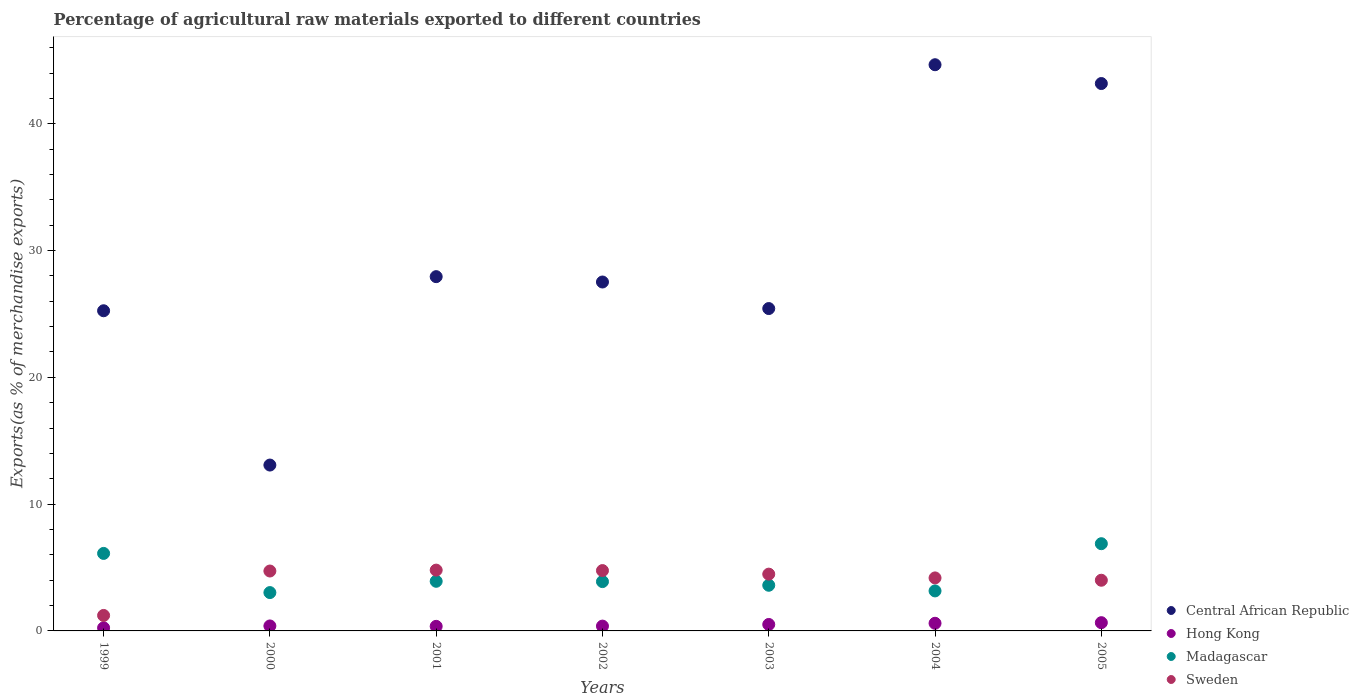What is the percentage of exports to different countries in Central African Republic in 2002?
Provide a succinct answer. 27.52. Across all years, what is the maximum percentage of exports to different countries in Hong Kong?
Make the answer very short. 0.65. Across all years, what is the minimum percentage of exports to different countries in Hong Kong?
Your response must be concise. 0.24. What is the total percentage of exports to different countries in Sweden in the graph?
Offer a very short reply. 28.15. What is the difference between the percentage of exports to different countries in Madagascar in 2002 and that in 2004?
Provide a short and direct response. 0.73. What is the difference between the percentage of exports to different countries in Hong Kong in 1999 and the percentage of exports to different countries in Madagascar in 2005?
Make the answer very short. -6.64. What is the average percentage of exports to different countries in Madagascar per year?
Offer a terse response. 4.37. In the year 2003, what is the difference between the percentage of exports to different countries in Hong Kong and percentage of exports to different countries in Central African Republic?
Give a very brief answer. -24.91. In how many years, is the percentage of exports to different countries in Madagascar greater than 16 %?
Your response must be concise. 0. What is the ratio of the percentage of exports to different countries in Hong Kong in 2002 to that in 2004?
Provide a succinct answer. 0.63. Is the difference between the percentage of exports to different countries in Hong Kong in 1999 and 2002 greater than the difference between the percentage of exports to different countries in Central African Republic in 1999 and 2002?
Your answer should be very brief. Yes. What is the difference between the highest and the second highest percentage of exports to different countries in Sweden?
Provide a short and direct response. 0.04. What is the difference between the highest and the lowest percentage of exports to different countries in Hong Kong?
Ensure brevity in your answer.  0.41. In how many years, is the percentage of exports to different countries in Central African Republic greater than the average percentage of exports to different countries in Central African Republic taken over all years?
Offer a terse response. 2. Is the sum of the percentage of exports to different countries in Madagascar in 2003 and 2005 greater than the maximum percentage of exports to different countries in Hong Kong across all years?
Give a very brief answer. Yes. Is it the case that in every year, the sum of the percentage of exports to different countries in Central African Republic and percentage of exports to different countries in Sweden  is greater than the sum of percentage of exports to different countries in Hong Kong and percentage of exports to different countries in Madagascar?
Your response must be concise. No. Is the percentage of exports to different countries in Central African Republic strictly greater than the percentage of exports to different countries in Madagascar over the years?
Your answer should be compact. Yes. Is the percentage of exports to different countries in Central African Republic strictly less than the percentage of exports to different countries in Hong Kong over the years?
Give a very brief answer. No. How many dotlines are there?
Provide a succinct answer. 4. How many years are there in the graph?
Your answer should be very brief. 7. How many legend labels are there?
Your answer should be very brief. 4. What is the title of the graph?
Your answer should be very brief. Percentage of agricultural raw materials exported to different countries. What is the label or title of the Y-axis?
Provide a succinct answer. Exports(as % of merchandise exports). What is the Exports(as % of merchandise exports) of Central African Republic in 1999?
Provide a short and direct response. 25.25. What is the Exports(as % of merchandise exports) of Hong Kong in 1999?
Your answer should be very brief. 0.24. What is the Exports(as % of merchandise exports) in Madagascar in 1999?
Provide a short and direct response. 6.11. What is the Exports(as % of merchandise exports) of Sweden in 1999?
Offer a terse response. 1.22. What is the Exports(as % of merchandise exports) in Central African Republic in 2000?
Give a very brief answer. 13.08. What is the Exports(as % of merchandise exports) of Hong Kong in 2000?
Your answer should be compact. 0.39. What is the Exports(as % of merchandise exports) of Madagascar in 2000?
Your answer should be compact. 3.02. What is the Exports(as % of merchandise exports) of Sweden in 2000?
Offer a terse response. 4.72. What is the Exports(as % of merchandise exports) in Central African Republic in 2001?
Offer a terse response. 27.94. What is the Exports(as % of merchandise exports) of Hong Kong in 2001?
Offer a terse response. 0.36. What is the Exports(as % of merchandise exports) in Madagascar in 2001?
Your answer should be compact. 3.91. What is the Exports(as % of merchandise exports) in Sweden in 2001?
Offer a very short reply. 4.8. What is the Exports(as % of merchandise exports) in Central African Republic in 2002?
Ensure brevity in your answer.  27.52. What is the Exports(as % of merchandise exports) in Hong Kong in 2002?
Offer a very short reply. 0.38. What is the Exports(as % of merchandise exports) in Madagascar in 2002?
Offer a terse response. 3.89. What is the Exports(as % of merchandise exports) of Sweden in 2002?
Make the answer very short. 4.76. What is the Exports(as % of merchandise exports) of Central African Republic in 2003?
Make the answer very short. 25.42. What is the Exports(as % of merchandise exports) of Hong Kong in 2003?
Your response must be concise. 0.51. What is the Exports(as % of merchandise exports) in Madagascar in 2003?
Give a very brief answer. 3.6. What is the Exports(as % of merchandise exports) in Sweden in 2003?
Your answer should be compact. 4.48. What is the Exports(as % of merchandise exports) of Central African Republic in 2004?
Make the answer very short. 44.65. What is the Exports(as % of merchandise exports) of Hong Kong in 2004?
Make the answer very short. 0.6. What is the Exports(as % of merchandise exports) in Madagascar in 2004?
Make the answer very short. 3.16. What is the Exports(as % of merchandise exports) in Sweden in 2004?
Provide a succinct answer. 4.18. What is the Exports(as % of merchandise exports) of Central African Republic in 2005?
Ensure brevity in your answer.  43.17. What is the Exports(as % of merchandise exports) of Hong Kong in 2005?
Provide a short and direct response. 0.65. What is the Exports(as % of merchandise exports) of Madagascar in 2005?
Ensure brevity in your answer.  6.88. What is the Exports(as % of merchandise exports) in Sweden in 2005?
Keep it short and to the point. 4. Across all years, what is the maximum Exports(as % of merchandise exports) of Central African Republic?
Provide a succinct answer. 44.65. Across all years, what is the maximum Exports(as % of merchandise exports) of Hong Kong?
Provide a short and direct response. 0.65. Across all years, what is the maximum Exports(as % of merchandise exports) in Madagascar?
Your response must be concise. 6.88. Across all years, what is the maximum Exports(as % of merchandise exports) in Sweden?
Offer a terse response. 4.8. Across all years, what is the minimum Exports(as % of merchandise exports) of Central African Republic?
Keep it short and to the point. 13.08. Across all years, what is the minimum Exports(as % of merchandise exports) of Hong Kong?
Give a very brief answer. 0.24. Across all years, what is the minimum Exports(as % of merchandise exports) of Madagascar?
Ensure brevity in your answer.  3.02. Across all years, what is the minimum Exports(as % of merchandise exports) in Sweden?
Your answer should be very brief. 1.22. What is the total Exports(as % of merchandise exports) of Central African Republic in the graph?
Your answer should be very brief. 207.03. What is the total Exports(as % of merchandise exports) of Hong Kong in the graph?
Your answer should be compact. 3.14. What is the total Exports(as % of merchandise exports) of Madagascar in the graph?
Your response must be concise. 30.57. What is the total Exports(as % of merchandise exports) of Sweden in the graph?
Your answer should be compact. 28.15. What is the difference between the Exports(as % of merchandise exports) of Central African Republic in 1999 and that in 2000?
Provide a succinct answer. 12.17. What is the difference between the Exports(as % of merchandise exports) of Hong Kong in 1999 and that in 2000?
Ensure brevity in your answer.  -0.15. What is the difference between the Exports(as % of merchandise exports) of Madagascar in 1999 and that in 2000?
Ensure brevity in your answer.  3.09. What is the difference between the Exports(as % of merchandise exports) of Sweden in 1999 and that in 2000?
Provide a short and direct response. -3.5. What is the difference between the Exports(as % of merchandise exports) in Central African Republic in 1999 and that in 2001?
Provide a succinct answer. -2.69. What is the difference between the Exports(as % of merchandise exports) in Hong Kong in 1999 and that in 2001?
Provide a succinct answer. -0.12. What is the difference between the Exports(as % of merchandise exports) in Madagascar in 1999 and that in 2001?
Offer a very short reply. 2.2. What is the difference between the Exports(as % of merchandise exports) in Sweden in 1999 and that in 2001?
Give a very brief answer. -3.57. What is the difference between the Exports(as % of merchandise exports) in Central African Republic in 1999 and that in 2002?
Provide a succinct answer. -2.27. What is the difference between the Exports(as % of merchandise exports) in Hong Kong in 1999 and that in 2002?
Offer a very short reply. -0.14. What is the difference between the Exports(as % of merchandise exports) of Madagascar in 1999 and that in 2002?
Give a very brief answer. 2.22. What is the difference between the Exports(as % of merchandise exports) of Sweden in 1999 and that in 2002?
Your answer should be compact. -3.54. What is the difference between the Exports(as % of merchandise exports) in Central African Republic in 1999 and that in 2003?
Your answer should be compact. -0.17. What is the difference between the Exports(as % of merchandise exports) of Hong Kong in 1999 and that in 2003?
Ensure brevity in your answer.  -0.27. What is the difference between the Exports(as % of merchandise exports) in Madagascar in 1999 and that in 2003?
Your response must be concise. 2.51. What is the difference between the Exports(as % of merchandise exports) in Sweden in 1999 and that in 2003?
Give a very brief answer. -3.26. What is the difference between the Exports(as % of merchandise exports) of Central African Republic in 1999 and that in 2004?
Your response must be concise. -19.4. What is the difference between the Exports(as % of merchandise exports) of Hong Kong in 1999 and that in 2004?
Ensure brevity in your answer.  -0.36. What is the difference between the Exports(as % of merchandise exports) of Madagascar in 1999 and that in 2004?
Provide a short and direct response. 2.96. What is the difference between the Exports(as % of merchandise exports) of Sweden in 1999 and that in 2004?
Ensure brevity in your answer.  -2.96. What is the difference between the Exports(as % of merchandise exports) in Central African Republic in 1999 and that in 2005?
Make the answer very short. -17.92. What is the difference between the Exports(as % of merchandise exports) of Hong Kong in 1999 and that in 2005?
Offer a very short reply. -0.41. What is the difference between the Exports(as % of merchandise exports) of Madagascar in 1999 and that in 2005?
Give a very brief answer. -0.77. What is the difference between the Exports(as % of merchandise exports) of Sweden in 1999 and that in 2005?
Offer a terse response. -2.78. What is the difference between the Exports(as % of merchandise exports) in Central African Republic in 2000 and that in 2001?
Make the answer very short. -14.86. What is the difference between the Exports(as % of merchandise exports) in Hong Kong in 2000 and that in 2001?
Give a very brief answer. 0.03. What is the difference between the Exports(as % of merchandise exports) in Madagascar in 2000 and that in 2001?
Provide a short and direct response. -0.89. What is the difference between the Exports(as % of merchandise exports) of Sweden in 2000 and that in 2001?
Offer a very short reply. -0.07. What is the difference between the Exports(as % of merchandise exports) of Central African Republic in 2000 and that in 2002?
Give a very brief answer. -14.44. What is the difference between the Exports(as % of merchandise exports) in Hong Kong in 2000 and that in 2002?
Provide a succinct answer. 0.01. What is the difference between the Exports(as % of merchandise exports) of Madagascar in 2000 and that in 2002?
Make the answer very short. -0.87. What is the difference between the Exports(as % of merchandise exports) of Sweden in 2000 and that in 2002?
Ensure brevity in your answer.  -0.03. What is the difference between the Exports(as % of merchandise exports) of Central African Republic in 2000 and that in 2003?
Provide a short and direct response. -12.34. What is the difference between the Exports(as % of merchandise exports) in Hong Kong in 2000 and that in 2003?
Your answer should be compact. -0.12. What is the difference between the Exports(as % of merchandise exports) of Madagascar in 2000 and that in 2003?
Give a very brief answer. -0.58. What is the difference between the Exports(as % of merchandise exports) of Sweden in 2000 and that in 2003?
Ensure brevity in your answer.  0.25. What is the difference between the Exports(as % of merchandise exports) of Central African Republic in 2000 and that in 2004?
Keep it short and to the point. -31.57. What is the difference between the Exports(as % of merchandise exports) in Hong Kong in 2000 and that in 2004?
Offer a very short reply. -0.21. What is the difference between the Exports(as % of merchandise exports) in Madagascar in 2000 and that in 2004?
Your response must be concise. -0.13. What is the difference between the Exports(as % of merchandise exports) in Sweden in 2000 and that in 2004?
Offer a terse response. 0.54. What is the difference between the Exports(as % of merchandise exports) of Central African Republic in 2000 and that in 2005?
Your response must be concise. -30.09. What is the difference between the Exports(as % of merchandise exports) in Hong Kong in 2000 and that in 2005?
Your response must be concise. -0.26. What is the difference between the Exports(as % of merchandise exports) in Madagascar in 2000 and that in 2005?
Offer a very short reply. -3.85. What is the difference between the Exports(as % of merchandise exports) of Sweden in 2000 and that in 2005?
Ensure brevity in your answer.  0.73. What is the difference between the Exports(as % of merchandise exports) of Central African Republic in 2001 and that in 2002?
Keep it short and to the point. 0.42. What is the difference between the Exports(as % of merchandise exports) of Hong Kong in 2001 and that in 2002?
Provide a succinct answer. -0.02. What is the difference between the Exports(as % of merchandise exports) of Madagascar in 2001 and that in 2002?
Your answer should be compact. 0.02. What is the difference between the Exports(as % of merchandise exports) in Sweden in 2001 and that in 2002?
Your response must be concise. 0.04. What is the difference between the Exports(as % of merchandise exports) of Central African Republic in 2001 and that in 2003?
Provide a succinct answer. 2.52. What is the difference between the Exports(as % of merchandise exports) in Hong Kong in 2001 and that in 2003?
Your response must be concise. -0.15. What is the difference between the Exports(as % of merchandise exports) in Madagascar in 2001 and that in 2003?
Ensure brevity in your answer.  0.31. What is the difference between the Exports(as % of merchandise exports) of Sweden in 2001 and that in 2003?
Ensure brevity in your answer.  0.32. What is the difference between the Exports(as % of merchandise exports) of Central African Republic in 2001 and that in 2004?
Provide a short and direct response. -16.71. What is the difference between the Exports(as % of merchandise exports) of Hong Kong in 2001 and that in 2004?
Your response must be concise. -0.24. What is the difference between the Exports(as % of merchandise exports) in Madagascar in 2001 and that in 2004?
Keep it short and to the point. 0.76. What is the difference between the Exports(as % of merchandise exports) of Sweden in 2001 and that in 2004?
Keep it short and to the point. 0.61. What is the difference between the Exports(as % of merchandise exports) in Central African Republic in 2001 and that in 2005?
Provide a succinct answer. -15.23. What is the difference between the Exports(as % of merchandise exports) in Hong Kong in 2001 and that in 2005?
Your answer should be compact. -0.29. What is the difference between the Exports(as % of merchandise exports) of Madagascar in 2001 and that in 2005?
Ensure brevity in your answer.  -2.96. What is the difference between the Exports(as % of merchandise exports) in Sweden in 2001 and that in 2005?
Your response must be concise. 0.8. What is the difference between the Exports(as % of merchandise exports) in Central African Republic in 2002 and that in 2003?
Offer a terse response. 2.09. What is the difference between the Exports(as % of merchandise exports) of Hong Kong in 2002 and that in 2003?
Make the answer very short. -0.13. What is the difference between the Exports(as % of merchandise exports) in Madagascar in 2002 and that in 2003?
Your answer should be very brief. 0.29. What is the difference between the Exports(as % of merchandise exports) of Sweden in 2002 and that in 2003?
Make the answer very short. 0.28. What is the difference between the Exports(as % of merchandise exports) of Central African Republic in 2002 and that in 2004?
Your response must be concise. -17.14. What is the difference between the Exports(as % of merchandise exports) in Hong Kong in 2002 and that in 2004?
Offer a terse response. -0.22. What is the difference between the Exports(as % of merchandise exports) of Madagascar in 2002 and that in 2004?
Give a very brief answer. 0.73. What is the difference between the Exports(as % of merchandise exports) in Sweden in 2002 and that in 2004?
Offer a terse response. 0.58. What is the difference between the Exports(as % of merchandise exports) of Central African Republic in 2002 and that in 2005?
Provide a succinct answer. -15.65. What is the difference between the Exports(as % of merchandise exports) in Hong Kong in 2002 and that in 2005?
Keep it short and to the point. -0.27. What is the difference between the Exports(as % of merchandise exports) in Madagascar in 2002 and that in 2005?
Ensure brevity in your answer.  -2.99. What is the difference between the Exports(as % of merchandise exports) in Sweden in 2002 and that in 2005?
Keep it short and to the point. 0.76. What is the difference between the Exports(as % of merchandise exports) of Central African Republic in 2003 and that in 2004?
Your answer should be very brief. -19.23. What is the difference between the Exports(as % of merchandise exports) in Hong Kong in 2003 and that in 2004?
Your response must be concise. -0.09. What is the difference between the Exports(as % of merchandise exports) in Madagascar in 2003 and that in 2004?
Provide a short and direct response. 0.45. What is the difference between the Exports(as % of merchandise exports) of Sweden in 2003 and that in 2004?
Offer a very short reply. 0.3. What is the difference between the Exports(as % of merchandise exports) of Central African Republic in 2003 and that in 2005?
Your answer should be compact. -17.75. What is the difference between the Exports(as % of merchandise exports) of Hong Kong in 2003 and that in 2005?
Ensure brevity in your answer.  -0.14. What is the difference between the Exports(as % of merchandise exports) in Madagascar in 2003 and that in 2005?
Provide a short and direct response. -3.28. What is the difference between the Exports(as % of merchandise exports) of Sweden in 2003 and that in 2005?
Your response must be concise. 0.48. What is the difference between the Exports(as % of merchandise exports) in Central African Republic in 2004 and that in 2005?
Offer a very short reply. 1.48. What is the difference between the Exports(as % of merchandise exports) in Hong Kong in 2004 and that in 2005?
Your answer should be very brief. -0.05. What is the difference between the Exports(as % of merchandise exports) of Madagascar in 2004 and that in 2005?
Your answer should be compact. -3.72. What is the difference between the Exports(as % of merchandise exports) of Sweden in 2004 and that in 2005?
Your response must be concise. 0.18. What is the difference between the Exports(as % of merchandise exports) in Central African Republic in 1999 and the Exports(as % of merchandise exports) in Hong Kong in 2000?
Your response must be concise. 24.86. What is the difference between the Exports(as % of merchandise exports) of Central African Republic in 1999 and the Exports(as % of merchandise exports) of Madagascar in 2000?
Ensure brevity in your answer.  22.23. What is the difference between the Exports(as % of merchandise exports) in Central African Republic in 1999 and the Exports(as % of merchandise exports) in Sweden in 2000?
Offer a very short reply. 20.52. What is the difference between the Exports(as % of merchandise exports) of Hong Kong in 1999 and the Exports(as % of merchandise exports) of Madagascar in 2000?
Provide a succinct answer. -2.78. What is the difference between the Exports(as % of merchandise exports) in Hong Kong in 1999 and the Exports(as % of merchandise exports) in Sweden in 2000?
Offer a very short reply. -4.48. What is the difference between the Exports(as % of merchandise exports) of Madagascar in 1999 and the Exports(as % of merchandise exports) of Sweden in 2000?
Provide a short and direct response. 1.39. What is the difference between the Exports(as % of merchandise exports) in Central African Republic in 1999 and the Exports(as % of merchandise exports) in Hong Kong in 2001?
Your response must be concise. 24.89. What is the difference between the Exports(as % of merchandise exports) of Central African Republic in 1999 and the Exports(as % of merchandise exports) of Madagascar in 2001?
Your answer should be very brief. 21.33. What is the difference between the Exports(as % of merchandise exports) in Central African Republic in 1999 and the Exports(as % of merchandise exports) in Sweden in 2001?
Offer a very short reply. 20.45. What is the difference between the Exports(as % of merchandise exports) of Hong Kong in 1999 and the Exports(as % of merchandise exports) of Madagascar in 2001?
Offer a terse response. -3.67. What is the difference between the Exports(as % of merchandise exports) of Hong Kong in 1999 and the Exports(as % of merchandise exports) of Sweden in 2001?
Ensure brevity in your answer.  -4.55. What is the difference between the Exports(as % of merchandise exports) in Madagascar in 1999 and the Exports(as % of merchandise exports) in Sweden in 2001?
Your response must be concise. 1.32. What is the difference between the Exports(as % of merchandise exports) in Central African Republic in 1999 and the Exports(as % of merchandise exports) in Hong Kong in 2002?
Your response must be concise. 24.87. What is the difference between the Exports(as % of merchandise exports) of Central African Republic in 1999 and the Exports(as % of merchandise exports) of Madagascar in 2002?
Provide a succinct answer. 21.36. What is the difference between the Exports(as % of merchandise exports) of Central African Republic in 1999 and the Exports(as % of merchandise exports) of Sweden in 2002?
Your response must be concise. 20.49. What is the difference between the Exports(as % of merchandise exports) of Hong Kong in 1999 and the Exports(as % of merchandise exports) of Madagascar in 2002?
Keep it short and to the point. -3.65. What is the difference between the Exports(as % of merchandise exports) of Hong Kong in 1999 and the Exports(as % of merchandise exports) of Sweden in 2002?
Offer a terse response. -4.52. What is the difference between the Exports(as % of merchandise exports) of Madagascar in 1999 and the Exports(as % of merchandise exports) of Sweden in 2002?
Offer a very short reply. 1.35. What is the difference between the Exports(as % of merchandise exports) in Central African Republic in 1999 and the Exports(as % of merchandise exports) in Hong Kong in 2003?
Provide a succinct answer. 24.74. What is the difference between the Exports(as % of merchandise exports) of Central African Republic in 1999 and the Exports(as % of merchandise exports) of Madagascar in 2003?
Your answer should be compact. 21.65. What is the difference between the Exports(as % of merchandise exports) in Central African Republic in 1999 and the Exports(as % of merchandise exports) in Sweden in 2003?
Make the answer very short. 20.77. What is the difference between the Exports(as % of merchandise exports) of Hong Kong in 1999 and the Exports(as % of merchandise exports) of Madagascar in 2003?
Provide a short and direct response. -3.36. What is the difference between the Exports(as % of merchandise exports) in Hong Kong in 1999 and the Exports(as % of merchandise exports) in Sweden in 2003?
Your answer should be very brief. -4.24. What is the difference between the Exports(as % of merchandise exports) in Madagascar in 1999 and the Exports(as % of merchandise exports) in Sweden in 2003?
Make the answer very short. 1.63. What is the difference between the Exports(as % of merchandise exports) in Central African Republic in 1999 and the Exports(as % of merchandise exports) in Hong Kong in 2004?
Keep it short and to the point. 24.65. What is the difference between the Exports(as % of merchandise exports) in Central African Republic in 1999 and the Exports(as % of merchandise exports) in Madagascar in 2004?
Provide a succinct answer. 22.09. What is the difference between the Exports(as % of merchandise exports) in Central African Republic in 1999 and the Exports(as % of merchandise exports) in Sweden in 2004?
Keep it short and to the point. 21.07. What is the difference between the Exports(as % of merchandise exports) of Hong Kong in 1999 and the Exports(as % of merchandise exports) of Madagascar in 2004?
Provide a short and direct response. -2.91. What is the difference between the Exports(as % of merchandise exports) of Hong Kong in 1999 and the Exports(as % of merchandise exports) of Sweden in 2004?
Ensure brevity in your answer.  -3.94. What is the difference between the Exports(as % of merchandise exports) in Madagascar in 1999 and the Exports(as % of merchandise exports) in Sweden in 2004?
Give a very brief answer. 1.93. What is the difference between the Exports(as % of merchandise exports) of Central African Republic in 1999 and the Exports(as % of merchandise exports) of Hong Kong in 2005?
Offer a terse response. 24.6. What is the difference between the Exports(as % of merchandise exports) of Central African Republic in 1999 and the Exports(as % of merchandise exports) of Madagascar in 2005?
Ensure brevity in your answer.  18.37. What is the difference between the Exports(as % of merchandise exports) of Central African Republic in 1999 and the Exports(as % of merchandise exports) of Sweden in 2005?
Keep it short and to the point. 21.25. What is the difference between the Exports(as % of merchandise exports) in Hong Kong in 1999 and the Exports(as % of merchandise exports) in Madagascar in 2005?
Your response must be concise. -6.64. What is the difference between the Exports(as % of merchandise exports) of Hong Kong in 1999 and the Exports(as % of merchandise exports) of Sweden in 2005?
Offer a very short reply. -3.75. What is the difference between the Exports(as % of merchandise exports) in Madagascar in 1999 and the Exports(as % of merchandise exports) in Sweden in 2005?
Your answer should be compact. 2.12. What is the difference between the Exports(as % of merchandise exports) of Central African Republic in 2000 and the Exports(as % of merchandise exports) of Hong Kong in 2001?
Provide a short and direct response. 12.72. What is the difference between the Exports(as % of merchandise exports) in Central African Republic in 2000 and the Exports(as % of merchandise exports) in Madagascar in 2001?
Give a very brief answer. 9.17. What is the difference between the Exports(as % of merchandise exports) of Central African Republic in 2000 and the Exports(as % of merchandise exports) of Sweden in 2001?
Provide a short and direct response. 8.29. What is the difference between the Exports(as % of merchandise exports) of Hong Kong in 2000 and the Exports(as % of merchandise exports) of Madagascar in 2001?
Offer a terse response. -3.52. What is the difference between the Exports(as % of merchandise exports) of Hong Kong in 2000 and the Exports(as % of merchandise exports) of Sweden in 2001?
Your answer should be very brief. -4.4. What is the difference between the Exports(as % of merchandise exports) of Madagascar in 2000 and the Exports(as % of merchandise exports) of Sweden in 2001?
Your response must be concise. -1.77. What is the difference between the Exports(as % of merchandise exports) in Central African Republic in 2000 and the Exports(as % of merchandise exports) in Hong Kong in 2002?
Your answer should be very brief. 12.7. What is the difference between the Exports(as % of merchandise exports) of Central African Republic in 2000 and the Exports(as % of merchandise exports) of Madagascar in 2002?
Keep it short and to the point. 9.19. What is the difference between the Exports(as % of merchandise exports) in Central African Republic in 2000 and the Exports(as % of merchandise exports) in Sweden in 2002?
Your answer should be compact. 8.32. What is the difference between the Exports(as % of merchandise exports) of Hong Kong in 2000 and the Exports(as % of merchandise exports) of Madagascar in 2002?
Provide a short and direct response. -3.5. What is the difference between the Exports(as % of merchandise exports) in Hong Kong in 2000 and the Exports(as % of merchandise exports) in Sweden in 2002?
Offer a very short reply. -4.37. What is the difference between the Exports(as % of merchandise exports) of Madagascar in 2000 and the Exports(as % of merchandise exports) of Sweden in 2002?
Provide a succinct answer. -1.74. What is the difference between the Exports(as % of merchandise exports) of Central African Republic in 2000 and the Exports(as % of merchandise exports) of Hong Kong in 2003?
Provide a succinct answer. 12.57. What is the difference between the Exports(as % of merchandise exports) in Central African Republic in 2000 and the Exports(as % of merchandise exports) in Madagascar in 2003?
Keep it short and to the point. 9.48. What is the difference between the Exports(as % of merchandise exports) of Central African Republic in 2000 and the Exports(as % of merchandise exports) of Sweden in 2003?
Provide a short and direct response. 8.6. What is the difference between the Exports(as % of merchandise exports) of Hong Kong in 2000 and the Exports(as % of merchandise exports) of Madagascar in 2003?
Ensure brevity in your answer.  -3.21. What is the difference between the Exports(as % of merchandise exports) of Hong Kong in 2000 and the Exports(as % of merchandise exports) of Sweden in 2003?
Provide a succinct answer. -4.09. What is the difference between the Exports(as % of merchandise exports) in Madagascar in 2000 and the Exports(as % of merchandise exports) in Sweden in 2003?
Your answer should be very brief. -1.45. What is the difference between the Exports(as % of merchandise exports) of Central African Republic in 2000 and the Exports(as % of merchandise exports) of Hong Kong in 2004?
Your response must be concise. 12.48. What is the difference between the Exports(as % of merchandise exports) of Central African Republic in 2000 and the Exports(as % of merchandise exports) of Madagascar in 2004?
Offer a very short reply. 9.93. What is the difference between the Exports(as % of merchandise exports) of Central African Republic in 2000 and the Exports(as % of merchandise exports) of Sweden in 2004?
Offer a terse response. 8.9. What is the difference between the Exports(as % of merchandise exports) in Hong Kong in 2000 and the Exports(as % of merchandise exports) in Madagascar in 2004?
Provide a succinct answer. -2.76. What is the difference between the Exports(as % of merchandise exports) in Hong Kong in 2000 and the Exports(as % of merchandise exports) in Sweden in 2004?
Offer a terse response. -3.79. What is the difference between the Exports(as % of merchandise exports) of Madagascar in 2000 and the Exports(as % of merchandise exports) of Sweden in 2004?
Make the answer very short. -1.16. What is the difference between the Exports(as % of merchandise exports) of Central African Republic in 2000 and the Exports(as % of merchandise exports) of Hong Kong in 2005?
Offer a very short reply. 12.43. What is the difference between the Exports(as % of merchandise exports) of Central African Republic in 2000 and the Exports(as % of merchandise exports) of Madagascar in 2005?
Offer a terse response. 6.2. What is the difference between the Exports(as % of merchandise exports) in Central African Republic in 2000 and the Exports(as % of merchandise exports) in Sweden in 2005?
Your answer should be very brief. 9.08. What is the difference between the Exports(as % of merchandise exports) of Hong Kong in 2000 and the Exports(as % of merchandise exports) of Madagascar in 2005?
Your answer should be very brief. -6.49. What is the difference between the Exports(as % of merchandise exports) of Hong Kong in 2000 and the Exports(as % of merchandise exports) of Sweden in 2005?
Provide a succinct answer. -3.6. What is the difference between the Exports(as % of merchandise exports) of Madagascar in 2000 and the Exports(as % of merchandise exports) of Sweden in 2005?
Make the answer very short. -0.97. What is the difference between the Exports(as % of merchandise exports) in Central African Republic in 2001 and the Exports(as % of merchandise exports) in Hong Kong in 2002?
Offer a very short reply. 27.56. What is the difference between the Exports(as % of merchandise exports) of Central African Republic in 2001 and the Exports(as % of merchandise exports) of Madagascar in 2002?
Offer a terse response. 24.05. What is the difference between the Exports(as % of merchandise exports) in Central African Republic in 2001 and the Exports(as % of merchandise exports) in Sweden in 2002?
Keep it short and to the point. 23.18. What is the difference between the Exports(as % of merchandise exports) of Hong Kong in 2001 and the Exports(as % of merchandise exports) of Madagascar in 2002?
Keep it short and to the point. -3.53. What is the difference between the Exports(as % of merchandise exports) of Hong Kong in 2001 and the Exports(as % of merchandise exports) of Sweden in 2002?
Offer a terse response. -4.4. What is the difference between the Exports(as % of merchandise exports) of Madagascar in 2001 and the Exports(as % of merchandise exports) of Sweden in 2002?
Your answer should be very brief. -0.84. What is the difference between the Exports(as % of merchandise exports) of Central African Republic in 2001 and the Exports(as % of merchandise exports) of Hong Kong in 2003?
Your response must be concise. 27.43. What is the difference between the Exports(as % of merchandise exports) in Central African Republic in 2001 and the Exports(as % of merchandise exports) in Madagascar in 2003?
Keep it short and to the point. 24.34. What is the difference between the Exports(as % of merchandise exports) in Central African Republic in 2001 and the Exports(as % of merchandise exports) in Sweden in 2003?
Your response must be concise. 23.46. What is the difference between the Exports(as % of merchandise exports) in Hong Kong in 2001 and the Exports(as % of merchandise exports) in Madagascar in 2003?
Your answer should be compact. -3.24. What is the difference between the Exports(as % of merchandise exports) in Hong Kong in 2001 and the Exports(as % of merchandise exports) in Sweden in 2003?
Offer a terse response. -4.12. What is the difference between the Exports(as % of merchandise exports) of Madagascar in 2001 and the Exports(as % of merchandise exports) of Sweden in 2003?
Keep it short and to the point. -0.56. What is the difference between the Exports(as % of merchandise exports) in Central African Republic in 2001 and the Exports(as % of merchandise exports) in Hong Kong in 2004?
Your answer should be very brief. 27.34. What is the difference between the Exports(as % of merchandise exports) of Central African Republic in 2001 and the Exports(as % of merchandise exports) of Madagascar in 2004?
Provide a short and direct response. 24.78. What is the difference between the Exports(as % of merchandise exports) in Central African Republic in 2001 and the Exports(as % of merchandise exports) in Sweden in 2004?
Offer a terse response. 23.76. What is the difference between the Exports(as % of merchandise exports) of Hong Kong in 2001 and the Exports(as % of merchandise exports) of Madagascar in 2004?
Ensure brevity in your answer.  -2.79. What is the difference between the Exports(as % of merchandise exports) of Hong Kong in 2001 and the Exports(as % of merchandise exports) of Sweden in 2004?
Offer a terse response. -3.82. What is the difference between the Exports(as % of merchandise exports) of Madagascar in 2001 and the Exports(as % of merchandise exports) of Sweden in 2004?
Keep it short and to the point. -0.27. What is the difference between the Exports(as % of merchandise exports) in Central African Republic in 2001 and the Exports(as % of merchandise exports) in Hong Kong in 2005?
Offer a terse response. 27.29. What is the difference between the Exports(as % of merchandise exports) in Central African Republic in 2001 and the Exports(as % of merchandise exports) in Madagascar in 2005?
Your answer should be very brief. 21.06. What is the difference between the Exports(as % of merchandise exports) of Central African Republic in 2001 and the Exports(as % of merchandise exports) of Sweden in 2005?
Keep it short and to the point. 23.94. What is the difference between the Exports(as % of merchandise exports) in Hong Kong in 2001 and the Exports(as % of merchandise exports) in Madagascar in 2005?
Your response must be concise. -6.52. What is the difference between the Exports(as % of merchandise exports) in Hong Kong in 2001 and the Exports(as % of merchandise exports) in Sweden in 2005?
Your answer should be compact. -3.64. What is the difference between the Exports(as % of merchandise exports) of Madagascar in 2001 and the Exports(as % of merchandise exports) of Sweden in 2005?
Your answer should be very brief. -0.08. What is the difference between the Exports(as % of merchandise exports) in Central African Republic in 2002 and the Exports(as % of merchandise exports) in Hong Kong in 2003?
Provide a succinct answer. 27.01. What is the difference between the Exports(as % of merchandise exports) in Central African Republic in 2002 and the Exports(as % of merchandise exports) in Madagascar in 2003?
Ensure brevity in your answer.  23.92. What is the difference between the Exports(as % of merchandise exports) in Central African Republic in 2002 and the Exports(as % of merchandise exports) in Sweden in 2003?
Offer a terse response. 23.04. What is the difference between the Exports(as % of merchandise exports) of Hong Kong in 2002 and the Exports(as % of merchandise exports) of Madagascar in 2003?
Provide a succinct answer. -3.22. What is the difference between the Exports(as % of merchandise exports) in Hong Kong in 2002 and the Exports(as % of merchandise exports) in Sweden in 2003?
Keep it short and to the point. -4.1. What is the difference between the Exports(as % of merchandise exports) in Madagascar in 2002 and the Exports(as % of merchandise exports) in Sweden in 2003?
Your answer should be compact. -0.59. What is the difference between the Exports(as % of merchandise exports) in Central African Republic in 2002 and the Exports(as % of merchandise exports) in Hong Kong in 2004?
Offer a very short reply. 26.91. What is the difference between the Exports(as % of merchandise exports) in Central African Republic in 2002 and the Exports(as % of merchandise exports) in Madagascar in 2004?
Keep it short and to the point. 24.36. What is the difference between the Exports(as % of merchandise exports) in Central African Republic in 2002 and the Exports(as % of merchandise exports) in Sweden in 2004?
Offer a very short reply. 23.34. What is the difference between the Exports(as % of merchandise exports) in Hong Kong in 2002 and the Exports(as % of merchandise exports) in Madagascar in 2004?
Provide a succinct answer. -2.78. What is the difference between the Exports(as % of merchandise exports) in Hong Kong in 2002 and the Exports(as % of merchandise exports) in Sweden in 2004?
Your response must be concise. -3.8. What is the difference between the Exports(as % of merchandise exports) in Madagascar in 2002 and the Exports(as % of merchandise exports) in Sweden in 2004?
Your response must be concise. -0.29. What is the difference between the Exports(as % of merchandise exports) of Central African Republic in 2002 and the Exports(as % of merchandise exports) of Hong Kong in 2005?
Make the answer very short. 26.87. What is the difference between the Exports(as % of merchandise exports) of Central African Republic in 2002 and the Exports(as % of merchandise exports) of Madagascar in 2005?
Offer a very short reply. 20.64. What is the difference between the Exports(as % of merchandise exports) in Central African Republic in 2002 and the Exports(as % of merchandise exports) in Sweden in 2005?
Your answer should be very brief. 23.52. What is the difference between the Exports(as % of merchandise exports) of Hong Kong in 2002 and the Exports(as % of merchandise exports) of Madagascar in 2005?
Offer a terse response. -6.5. What is the difference between the Exports(as % of merchandise exports) in Hong Kong in 2002 and the Exports(as % of merchandise exports) in Sweden in 2005?
Offer a terse response. -3.62. What is the difference between the Exports(as % of merchandise exports) of Madagascar in 2002 and the Exports(as % of merchandise exports) of Sweden in 2005?
Your answer should be very brief. -0.11. What is the difference between the Exports(as % of merchandise exports) of Central African Republic in 2003 and the Exports(as % of merchandise exports) of Hong Kong in 2004?
Offer a terse response. 24.82. What is the difference between the Exports(as % of merchandise exports) in Central African Republic in 2003 and the Exports(as % of merchandise exports) in Madagascar in 2004?
Make the answer very short. 22.27. What is the difference between the Exports(as % of merchandise exports) in Central African Republic in 2003 and the Exports(as % of merchandise exports) in Sweden in 2004?
Give a very brief answer. 21.24. What is the difference between the Exports(as % of merchandise exports) in Hong Kong in 2003 and the Exports(as % of merchandise exports) in Madagascar in 2004?
Your answer should be compact. -2.65. What is the difference between the Exports(as % of merchandise exports) in Hong Kong in 2003 and the Exports(as % of merchandise exports) in Sweden in 2004?
Offer a very short reply. -3.67. What is the difference between the Exports(as % of merchandise exports) in Madagascar in 2003 and the Exports(as % of merchandise exports) in Sweden in 2004?
Your response must be concise. -0.58. What is the difference between the Exports(as % of merchandise exports) of Central African Republic in 2003 and the Exports(as % of merchandise exports) of Hong Kong in 2005?
Keep it short and to the point. 24.77. What is the difference between the Exports(as % of merchandise exports) in Central African Republic in 2003 and the Exports(as % of merchandise exports) in Madagascar in 2005?
Your answer should be compact. 18.54. What is the difference between the Exports(as % of merchandise exports) of Central African Republic in 2003 and the Exports(as % of merchandise exports) of Sweden in 2005?
Your response must be concise. 21.43. What is the difference between the Exports(as % of merchandise exports) of Hong Kong in 2003 and the Exports(as % of merchandise exports) of Madagascar in 2005?
Ensure brevity in your answer.  -6.37. What is the difference between the Exports(as % of merchandise exports) in Hong Kong in 2003 and the Exports(as % of merchandise exports) in Sweden in 2005?
Give a very brief answer. -3.49. What is the difference between the Exports(as % of merchandise exports) of Madagascar in 2003 and the Exports(as % of merchandise exports) of Sweden in 2005?
Your answer should be very brief. -0.4. What is the difference between the Exports(as % of merchandise exports) of Central African Republic in 2004 and the Exports(as % of merchandise exports) of Hong Kong in 2005?
Provide a succinct answer. 44. What is the difference between the Exports(as % of merchandise exports) of Central African Republic in 2004 and the Exports(as % of merchandise exports) of Madagascar in 2005?
Your answer should be compact. 37.77. What is the difference between the Exports(as % of merchandise exports) of Central African Republic in 2004 and the Exports(as % of merchandise exports) of Sweden in 2005?
Your answer should be compact. 40.66. What is the difference between the Exports(as % of merchandise exports) of Hong Kong in 2004 and the Exports(as % of merchandise exports) of Madagascar in 2005?
Offer a very short reply. -6.28. What is the difference between the Exports(as % of merchandise exports) of Hong Kong in 2004 and the Exports(as % of merchandise exports) of Sweden in 2005?
Provide a short and direct response. -3.39. What is the difference between the Exports(as % of merchandise exports) of Madagascar in 2004 and the Exports(as % of merchandise exports) of Sweden in 2005?
Provide a short and direct response. -0.84. What is the average Exports(as % of merchandise exports) in Central African Republic per year?
Your answer should be very brief. 29.58. What is the average Exports(as % of merchandise exports) of Hong Kong per year?
Give a very brief answer. 0.45. What is the average Exports(as % of merchandise exports) of Madagascar per year?
Provide a succinct answer. 4.37. What is the average Exports(as % of merchandise exports) in Sweden per year?
Offer a very short reply. 4.02. In the year 1999, what is the difference between the Exports(as % of merchandise exports) in Central African Republic and Exports(as % of merchandise exports) in Hong Kong?
Your response must be concise. 25.01. In the year 1999, what is the difference between the Exports(as % of merchandise exports) in Central African Republic and Exports(as % of merchandise exports) in Madagascar?
Your answer should be compact. 19.14. In the year 1999, what is the difference between the Exports(as % of merchandise exports) in Central African Republic and Exports(as % of merchandise exports) in Sweden?
Make the answer very short. 24.03. In the year 1999, what is the difference between the Exports(as % of merchandise exports) of Hong Kong and Exports(as % of merchandise exports) of Madagascar?
Offer a very short reply. -5.87. In the year 1999, what is the difference between the Exports(as % of merchandise exports) of Hong Kong and Exports(as % of merchandise exports) of Sweden?
Your answer should be very brief. -0.98. In the year 1999, what is the difference between the Exports(as % of merchandise exports) in Madagascar and Exports(as % of merchandise exports) in Sweden?
Provide a short and direct response. 4.89. In the year 2000, what is the difference between the Exports(as % of merchandise exports) of Central African Republic and Exports(as % of merchandise exports) of Hong Kong?
Your response must be concise. 12.69. In the year 2000, what is the difference between the Exports(as % of merchandise exports) in Central African Republic and Exports(as % of merchandise exports) in Madagascar?
Offer a very short reply. 10.06. In the year 2000, what is the difference between the Exports(as % of merchandise exports) of Central African Republic and Exports(as % of merchandise exports) of Sweden?
Your answer should be compact. 8.36. In the year 2000, what is the difference between the Exports(as % of merchandise exports) in Hong Kong and Exports(as % of merchandise exports) in Madagascar?
Give a very brief answer. -2.63. In the year 2000, what is the difference between the Exports(as % of merchandise exports) in Hong Kong and Exports(as % of merchandise exports) in Sweden?
Your answer should be very brief. -4.33. In the year 2000, what is the difference between the Exports(as % of merchandise exports) of Madagascar and Exports(as % of merchandise exports) of Sweden?
Provide a short and direct response. -1.7. In the year 2001, what is the difference between the Exports(as % of merchandise exports) in Central African Republic and Exports(as % of merchandise exports) in Hong Kong?
Offer a terse response. 27.58. In the year 2001, what is the difference between the Exports(as % of merchandise exports) of Central African Republic and Exports(as % of merchandise exports) of Madagascar?
Your answer should be compact. 24.02. In the year 2001, what is the difference between the Exports(as % of merchandise exports) of Central African Republic and Exports(as % of merchandise exports) of Sweden?
Your answer should be very brief. 23.14. In the year 2001, what is the difference between the Exports(as % of merchandise exports) in Hong Kong and Exports(as % of merchandise exports) in Madagascar?
Your answer should be very brief. -3.55. In the year 2001, what is the difference between the Exports(as % of merchandise exports) of Hong Kong and Exports(as % of merchandise exports) of Sweden?
Give a very brief answer. -4.43. In the year 2001, what is the difference between the Exports(as % of merchandise exports) of Madagascar and Exports(as % of merchandise exports) of Sweden?
Offer a terse response. -0.88. In the year 2002, what is the difference between the Exports(as % of merchandise exports) in Central African Republic and Exports(as % of merchandise exports) in Hong Kong?
Offer a very short reply. 27.14. In the year 2002, what is the difference between the Exports(as % of merchandise exports) in Central African Republic and Exports(as % of merchandise exports) in Madagascar?
Provide a short and direct response. 23.63. In the year 2002, what is the difference between the Exports(as % of merchandise exports) in Central African Republic and Exports(as % of merchandise exports) in Sweden?
Ensure brevity in your answer.  22.76. In the year 2002, what is the difference between the Exports(as % of merchandise exports) in Hong Kong and Exports(as % of merchandise exports) in Madagascar?
Offer a very short reply. -3.51. In the year 2002, what is the difference between the Exports(as % of merchandise exports) in Hong Kong and Exports(as % of merchandise exports) in Sweden?
Ensure brevity in your answer.  -4.38. In the year 2002, what is the difference between the Exports(as % of merchandise exports) in Madagascar and Exports(as % of merchandise exports) in Sweden?
Make the answer very short. -0.87. In the year 2003, what is the difference between the Exports(as % of merchandise exports) of Central African Republic and Exports(as % of merchandise exports) of Hong Kong?
Offer a very short reply. 24.91. In the year 2003, what is the difference between the Exports(as % of merchandise exports) of Central African Republic and Exports(as % of merchandise exports) of Madagascar?
Provide a succinct answer. 21.82. In the year 2003, what is the difference between the Exports(as % of merchandise exports) of Central African Republic and Exports(as % of merchandise exports) of Sweden?
Offer a very short reply. 20.95. In the year 2003, what is the difference between the Exports(as % of merchandise exports) of Hong Kong and Exports(as % of merchandise exports) of Madagascar?
Offer a very short reply. -3.09. In the year 2003, what is the difference between the Exports(as % of merchandise exports) in Hong Kong and Exports(as % of merchandise exports) in Sweden?
Your answer should be very brief. -3.97. In the year 2003, what is the difference between the Exports(as % of merchandise exports) in Madagascar and Exports(as % of merchandise exports) in Sweden?
Your answer should be compact. -0.88. In the year 2004, what is the difference between the Exports(as % of merchandise exports) of Central African Republic and Exports(as % of merchandise exports) of Hong Kong?
Your response must be concise. 44.05. In the year 2004, what is the difference between the Exports(as % of merchandise exports) in Central African Republic and Exports(as % of merchandise exports) in Madagascar?
Your response must be concise. 41.5. In the year 2004, what is the difference between the Exports(as % of merchandise exports) of Central African Republic and Exports(as % of merchandise exports) of Sweden?
Ensure brevity in your answer.  40.47. In the year 2004, what is the difference between the Exports(as % of merchandise exports) of Hong Kong and Exports(as % of merchandise exports) of Madagascar?
Offer a terse response. -2.55. In the year 2004, what is the difference between the Exports(as % of merchandise exports) of Hong Kong and Exports(as % of merchandise exports) of Sweden?
Give a very brief answer. -3.58. In the year 2004, what is the difference between the Exports(as % of merchandise exports) in Madagascar and Exports(as % of merchandise exports) in Sweden?
Your answer should be compact. -1.02. In the year 2005, what is the difference between the Exports(as % of merchandise exports) of Central African Republic and Exports(as % of merchandise exports) of Hong Kong?
Provide a succinct answer. 42.52. In the year 2005, what is the difference between the Exports(as % of merchandise exports) of Central African Republic and Exports(as % of merchandise exports) of Madagascar?
Offer a terse response. 36.29. In the year 2005, what is the difference between the Exports(as % of merchandise exports) in Central African Republic and Exports(as % of merchandise exports) in Sweden?
Provide a succinct answer. 39.17. In the year 2005, what is the difference between the Exports(as % of merchandise exports) of Hong Kong and Exports(as % of merchandise exports) of Madagascar?
Make the answer very short. -6.23. In the year 2005, what is the difference between the Exports(as % of merchandise exports) in Hong Kong and Exports(as % of merchandise exports) in Sweden?
Provide a short and direct response. -3.35. In the year 2005, what is the difference between the Exports(as % of merchandise exports) of Madagascar and Exports(as % of merchandise exports) of Sweden?
Provide a short and direct response. 2.88. What is the ratio of the Exports(as % of merchandise exports) of Central African Republic in 1999 to that in 2000?
Offer a very short reply. 1.93. What is the ratio of the Exports(as % of merchandise exports) in Hong Kong in 1999 to that in 2000?
Provide a short and direct response. 0.62. What is the ratio of the Exports(as % of merchandise exports) in Madagascar in 1999 to that in 2000?
Keep it short and to the point. 2.02. What is the ratio of the Exports(as % of merchandise exports) of Sweden in 1999 to that in 2000?
Your answer should be very brief. 0.26. What is the ratio of the Exports(as % of merchandise exports) in Central African Republic in 1999 to that in 2001?
Offer a very short reply. 0.9. What is the ratio of the Exports(as % of merchandise exports) of Hong Kong in 1999 to that in 2001?
Provide a short and direct response. 0.67. What is the ratio of the Exports(as % of merchandise exports) of Madagascar in 1999 to that in 2001?
Your answer should be compact. 1.56. What is the ratio of the Exports(as % of merchandise exports) of Sweden in 1999 to that in 2001?
Your response must be concise. 0.25. What is the ratio of the Exports(as % of merchandise exports) of Central African Republic in 1999 to that in 2002?
Your answer should be compact. 0.92. What is the ratio of the Exports(as % of merchandise exports) of Hong Kong in 1999 to that in 2002?
Offer a terse response. 0.64. What is the ratio of the Exports(as % of merchandise exports) of Madagascar in 1999 to that in 2002?
Ensure brevity in your answer.  1.57. What is the ratio of the Exports(as % of merchandise exports) of Sweden in 1999 to that in 2002?
Keep it short and to the point. 0.26. What is the ratio of the Exports(as % of merchandise exports) in Central African Republic in 1999 to that in 2003?
Give a very brief answer. 0.99. What is the ratio of the Exports(as % of merchandise exports) in Hong Kong in 1999 to that in 2003?
Make the answer very short. 0.48. What is the ratio of the Exports(as % of merchandise exports) in Madagascar in 1999 to that in 2003?
Ensure brevity in your answer.  1.7. What is the ratio of the Exports(as % of merchandise exports) of Sweden in 1999 to that in 2003?
Offer a terse response. 0.27. What is the ratio of the Exports(as % of merchandise exports) in Central African Republic in 1999 to that in 2004?
Offer a very short reply. 0.57. What is the ratio of the Exports(as % of merchandise exports) in Hong Kong in 1999 to that in 2004?
Your response must be concise. 0.4. What is the ratio of the Exports(as % of merchandise exports) of Madagascar in 1999 to that in 2004?
Ensure brevity in your answer.  1.94. What is the ratio of the Exports(as % of merchandise exports) in Sweden in 1999 to that in 2004?
Offer a very short reply. 0.29. What is the ratio of the Exports(as % of merchandise exports) of Central African Republic in 1999 to that in 2005?
Ensure brevity in your answer.  0.58. What is the ratio of the Exports(as % of merchandise exports) in Hong Kong in 1999 to that in 2005?
Your answer should be compact. 0.37. What is the ratio of the Exports(as % of merchandise exports) of Madagascar in 1999 to that in 2005?
Offer a very short reply. 0.89. What is the ratio of the Exports(as % of merchandise exports) in Sweden in 1999 to that in 2005?
Make the answer very short. 0.31. What is the ratio of the Exports(as % of merchandise exports) in Central African Republic in 2000 to that in 2001?
Your answer should be compact. 0.47. What is the ratio of the Exports(as % of merchandise exports) in Hong Kong in 2000 to that in 2001?
Your response must be concise. 1.09. What is the ratio of the Exports(as % of merchandise exports) in Madagascar in 2000 to that in 2001?
Offer a very short reply. 0.77. What is the ratio of the Exports(as % of merchandise exports) in Central African Republic in 2000 to that in 2002?
Ensure brevity in your answer.  0.48. What is the ratio of the Exports(as % of merchandise exports) of Hong Kong in 2000 to that in 2002?
Ensure brevity in your answer.  1.03. What is the ratio of the Exports(as % of merchandise exports) of Madagascar in 2000 to that in 2002?
Your answer should be compact. 0.78. What is the ratio of the Exports(as % of merchandise exports) in Central African Republic in 2000 to that in 2003?
Give a very brief answer. 0.51. What is the ratio of the Exports(as % of merchandise exports) of Hong Kong in 2000 to that in 2003?
Make the answer very short. 0.77. What is the ratio of the Exports(as % of merchandise exports) of Madagascar in 2000 to that in 2003?
Your answer should be very brief. 0.84. What is the ratio of the Exports(as % of merchandise exports) of Sweden in 2000 to that in 2003?
Your answer should be very brief. 1.05. What is the ratio of the Exports(as % of merchandise exports) of Central African Republic in 2000 to that in 2004?
Provide a short and direct response. 0.29. What is the ratio of the Exports(as % of merchandise exports) of Hong Kong in 2000 to that in 2004?
Your response must be concise. 0.65. What is the ratio of the Exports(as % of merchandise exports) in Sweden in 2000 to that in 2004?
Your response must be concise. 1.13. What is the ratio of the Exports(as % of merchandise exports) in Central African Republic in 2000 to that in 2005?
Your answer should be compact. 0.3. What is the ratio of the Exports(as % of merchandise exports) of Hong Kong in 2000 to that in 2005?
Ensure brevity in your answer.  0.6. What is the ratio of the Exports(as % of merchandise exports) in Madagascar in 2000 to that in 2005?
Your answer should be very brief. 0.44. What is the ratio of the Exports(as % of merchandise exports) of Sweden in 2000 to that in 2005?
Offer a terse response. 1.18. What is the ratio of the Exports(as % of merchandise exports) in Central African Republic in 2001 to that in 2002?
Your answer should be compact. 1.02. What is the ratio of the Exports(as % of merchandise exports) of Hong Kong in 2001 to that in 2002?
Your answer should be very brief. 0.95. What is the ratio of the Exports(as % of merchandise exports) of Sweden in 2001 to that in 2002?
Ensure brevity in your answer.  1.01. What is the ratio of the Exports(as % of merchandise exports) of Central African Republic in 2001 to that in 2003?
Your answer should be compact. 1.1. What is the ratio of the Exports(as % of merchandise exports) of Hong Kong in 2001 to that in 2003?
Offer a very short reply. 0.71. What is the ratio of the Exports(as % of merchandise exports) of Madagascar in 2001 to that in 2003?
Ensure brevity in your answer.  1.09. What is the ratio of the Exports(as % of merchandise exports) in Sweden in 2001 to that in 2003?
Give a very brief answer. 1.07. What is the ratio of the Exports(as % of merchandise exports) of Central African Republic in 2001 to that in 2004?
Offer a terse response. 0.63. What is the ratio of the Exports(as % of merchandise exports) in Hong Kong in 2001 to that in 2004?
Offer a very short reply. 0.6. What is the ratio of the Exports(as % of merchandise exports) of Madagascar in 2001 to that in 2004?
Keep it short and to the point. 1.24. What is the ratio of the Exports(as % of merchandise exports) of Sweden in 2001 to that in 2004?
Provide a short and direct response. 1.15. What is the ratio of the Exports(as % of merchandise exports) of Central African Republic in 2001 to that in 2005?
Provide a succinct answer. 0.65. What is the ratio of the Exports(as % of merchandise exports) in Hong Kong in 2001 to that in 2005?
Your answer should be very brief. 0.56. What is the ratio of the Exports(as % of merchandise exports) of Madagascar in 2001 to that in 2005?
Give a very brief answer. 0.57. What is the ratio of the Exports(as % of merchandise exports) of Sweden in 2001 to that in 2005?
Offer a terse response. 1.2. What is the ratio of the Exports(as % of merchandise exports) in Central African Republic in 2002 to that in 2003?
Your answer should be very brief. 1.08. What is the ratio of the Exports(as % of merchandise exports) of Hong Kong in 2002 to that in 2003?
Provide a short and direct response. 0.75. What is the ratio of the Exports(as % of merchandise exports) of Madagascar in 2002 to that in 2003?
Your answer should be very brief. 1.08. What is the ratio of the Exports(as % of merchandise exports) of Sweden in 2002 to that in 2003?
Ensure brevity in your answer.  1.06. What is the ratio of the Exports(as % of merchandise exports) of Central African Republic in 2002 to that in 2004?
Provide a succinct answer. 0.62. What is the ratio of the Exports(as % of merchandise exports) of Hong Kong in 2002 to that in 2004?
Keep it short and to the point. 0.63. What is the ratio of the Exports(as % of merchandise exports) in Madagascar in 2002 to that in 2004?
Provide a succinct answer. 1.23. What is the ratio of the Exports(as % of merchandise exports) in Sweden in 2002 to that in 2004?
Give a very brief answer. 1.14. What is the ratio of the Exports(as % of merchandise exports) of Central African Republic in 2002 to that in 2005?
Provide a succinct answer. 0.64. What is the ratio of the Exports(as % of merchandise exports) of Hong Kong in 2002 to that in 2005?
Your answer should be very brief. 0.58. What is the ratio of the Exports(as % of merchandise exports) in Madagascar in 2002 to that in 2005?
Your answer should be very brief. 0.57. What is the ratio of the Exports(as % of merchandise exports) of Sweden in 2002 to that in 2005?
Make the answer very short. 1.19. What is the ratio of the Exports(as % of merchandise exports) in Central African Republic in 2003 to that in 2004?
Make the answer very short. 0.57. What is the ratio of the Exports(as % of merchandise exports) of Hong Kong in 2003 to that in 2004?
Offer a very short reply. 0.84. What is the ratio of the Exports(as % of merchandise exports) of Madagascar in 2003 to that in 2004?
Give a very brief answer. 1.14. What is the ratio of the Exports(as % of merchandise exports) in Sweden in 2003 to that in 2004?
Your response must be concise. 1.07. What is the ratio of the Exports(as % of merchandise exports) of Central African Republic in 2003 to that in 2005?
Your answer should be compact. 0.59. What is the ratio of the Exports(as % of merchandise exports) in Hong Kong in 2003 to that in 2005?
Your answer should be very brief. 0.78. What is the ratio of the Exports(as % of merchandise exports) in Madagascar in 2003 to that in 2005?
Give a very brief answer. 0.52. What is the ratio of the Exports(as % of merchandise exports) in Sweden in 2003 to that in 2005?
Offer a very short reply. 1.12. What is the ratio of the Exports(as % of merchandise exports) of Central African Republic in 2004 to that in 2005?
Keep it short and to the point. 1.03. What is the ratio of the Exports(as % of merchandise exports) in Hong Kong in 2004 to that in 2005?
Offer a very short reply. 0.93. What is the ratio of the Exports(as % of merchandise exports) of Madagascar in 2004 to that in 2005?
Offer a very short reply. 0.46. What is the ratio of the Exports(as % of merchandise exports) of Sweden in 2004 to that in 2005?
Provide a succinct answer. 1.05. What is the difference between the highest and the second highest Exports(as % of merchandise exports) in Central African Republic?
Keep it short and to the point. 1.48. What is the difference between the highest and the second highest Exports(as % of merchandise exports) in Hong Kong?
Make the answer very short. 0.05. What is the difference between the highest and the second highest Exports(as % of merchandise exports) of Madagascar?
Keep it short and to the point. 0.77. What is the difference between the highest and the second highest Exports(as % of merchandise exports) of Sweden?
Keep it short and to the point. 0.04. What is the difference between the highest and the lowest Exports(as % of merchandise exports) in Central African Republic?
Keep it short and to the point. 31.57. What is the difference between the highest and the lowest Exports(as % of merchandise exports) of Hong Kong?
Provide a succinct answer. 0.41. What is the difference between the highest and the lowest Exports(as % of merchandise exports) of Madagascar?
Make the answer very short. 3.85. What is the difference between the highest and the lowest Exports(as % of merchandise exports) of Sweden?
Your response must be concise. 3.57. 